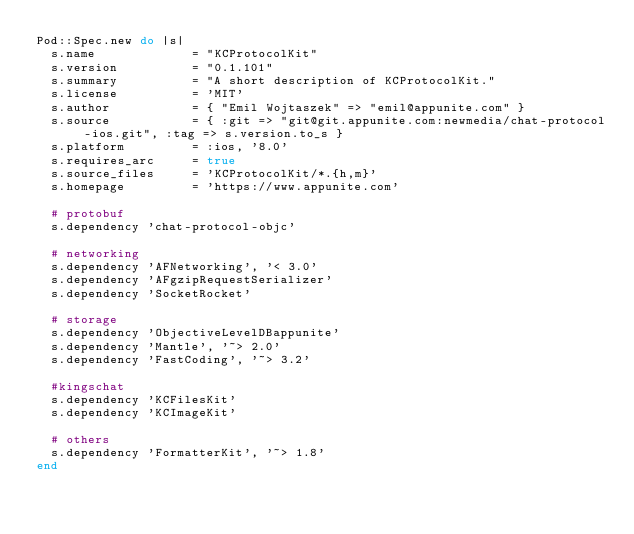<code> <loc_0><loc_0><loc_500><loc_500><_Ruby_>Pod::Spec.new do |s|
  s.name             = "KCProtocolKit"
  s.version          = "0.1.101"
  s.summary          = "A short description of KCProtocolKit."
  s.license          = 'MIT'
  s.author           = { "Emil Wojtaszek" => "emil@appunite.com" }
  s.source           = { :git => "git@git.appunite.com:newmedia/chat-protocol-ios.git", :tag => s.version.to_s }
  s.platform         = :ios, '8.0'
  s.requires_arc     = true
  s.source_files     = 'KCProtocolKit/*.{h,m}'
  s.homepage         = 'https://www.appunite.com'

  # protobuf  
  s.dependency 'chat-protocol-objc'

  # networking
  s.dependency 'AFNetworking', '< 3.0'
  s.dependency 'AFgzipRequestSerializer'
  s.dependency 'SocketRocket'

  # storage
  s.dependency 'ObjectiveLevelDBappunite'
  s.dependency 'Mantle', '~> 2.0'
  s.dependency 'FastCoding', '~> 3.2'

  #kingschat
  s.dependency 'KCFilesKit'
  s.dependency 'KCImageKit'
  
  # others
  s.dependency 'FormatterKit', '~> 1.8'
end</code> 